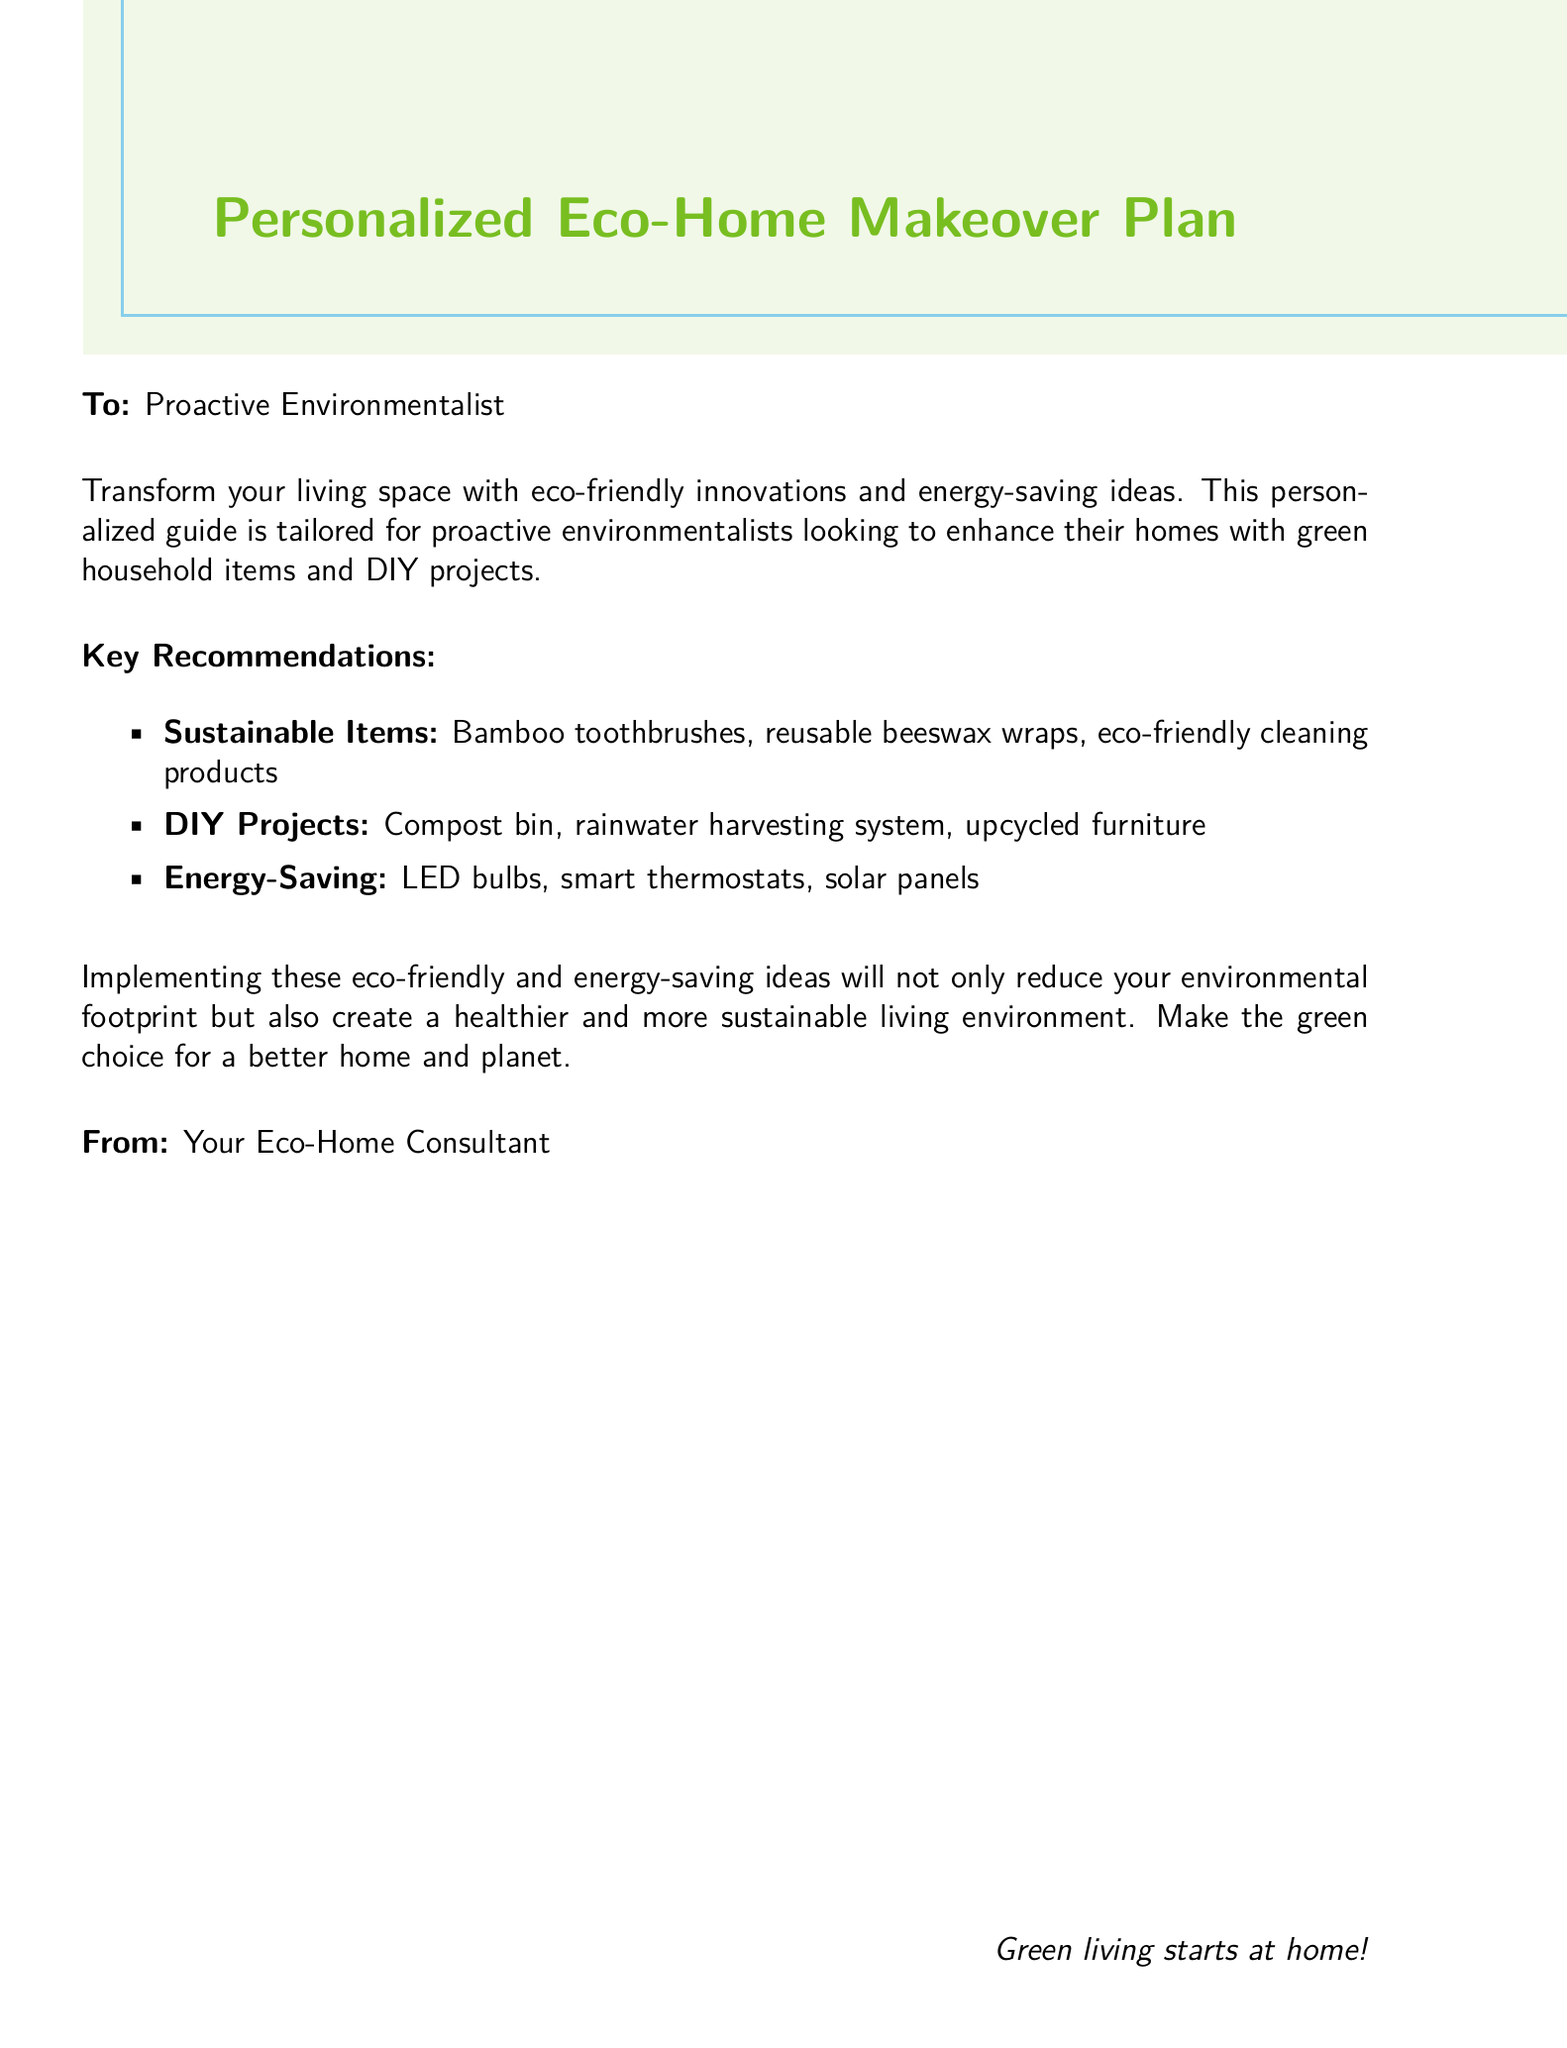What is the title of the document? The title is prominently displayed at the top of the document in large font.
Answer: Personalized Eco-Home Makeover Plan Who is the document addressed to? The recipient's designation is specified in the greeting section of the letter.
Answer: Proactive Environmentalist What are sustainable items mentioned? Sustainable items are listed in the key recommendations section of the document.
Answer: Bamboo toothbrushes, reusable beeswax wraps, eco-friendly cleaning products What is one DIY project suggested? The document lists various DIY projects under the recommendations.
Answer: Compost bin How do these recommendations benefit the home? The document states the overall benefit of implementing the recommendations.
Answer: Create a healthier and more sustainable living environment Who is the sender of the document? The sender's designation is indicated at the bottom of the document.
Answer: Your Eco-Home Consultant What color is used for the document's borders? The document mentions the color used for the borders in the design.
Answer: Sky blue What energy-saving item is recommended? The document includes a specific item in the energy-saving recommendations.
Answer: LED bulbs 